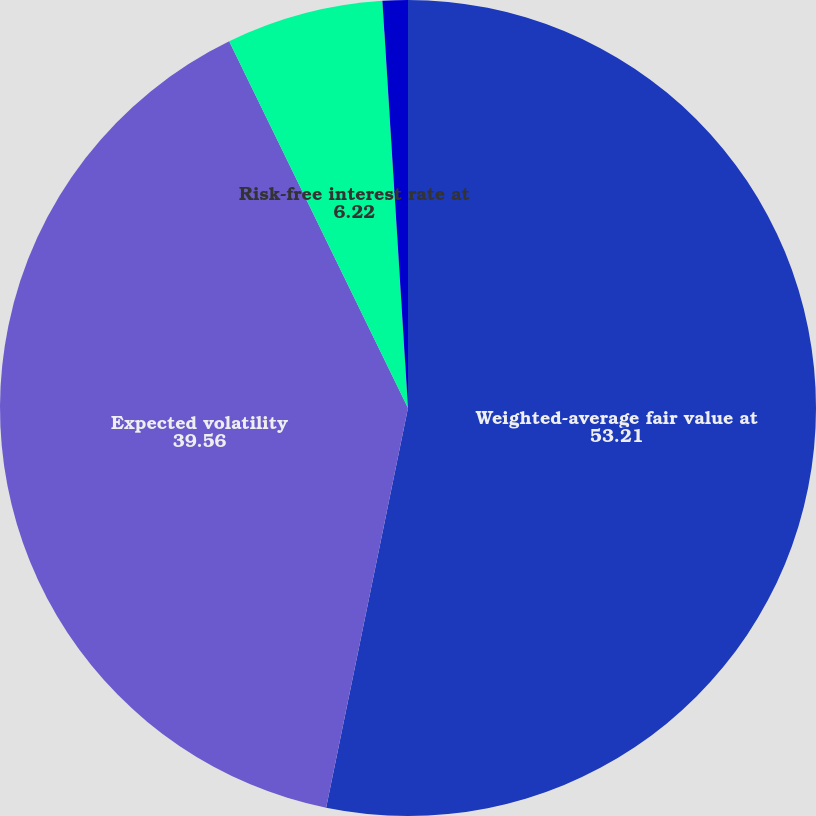<chart> <loc_0><loc_0><loc_500><loc_500><pie_chart><fcel>Weighted-average fair value at<fcel>Expected volatility<fcel>Risk-free interest rate at<fcel>Dividend yield<nl><fcel>53.21%<fcel>39.56%<fcel>6.22%<fcel>1.0%<nl></chart> 